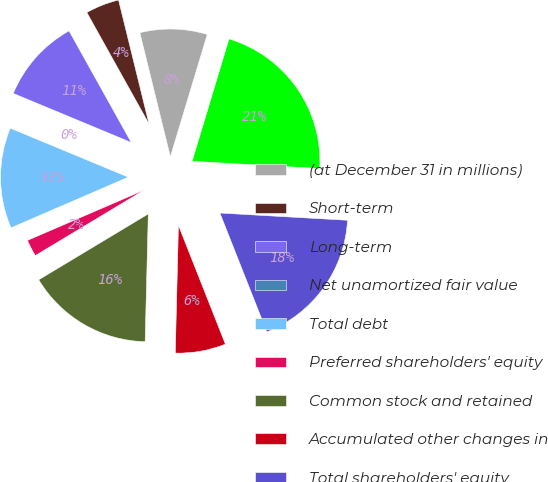Convert chart to OTSL. <chart><loc_0><loc_0><loc_500><loc_500><pie_chart><fcel>(at December 31 in millions)<fcel>Short-term<fcel>Long-term<fcel>Net unamortized fair value<fcel>Total debt<fcel>Preferred shareholders' equity<fcel>Common stock and retained<fcel>Accumulated other changes in<fcel>Total shareholders' equity<fcel>Total capitalization<nl><fcel>8.5%<fcel>4.26%<fcel>10.63%<fcel>0.01%<fcel>12.75%<fcel>2.13%<fcel>15.99%<fcel>6.38%<fcel>18.11%<fcel>21.24%<nl></chart> 